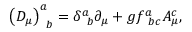<formula> <loc_0><loc_0><loc_500><loc_500>\left ( D _ { \mu } \right ) _ { \, b } ^ { a } = \delta _ { \, b } ^ { a } \partial _ { \mu } + g f _ { \, b c } ^ { a } A _ { \mu } ^ { c } ,</formula> 